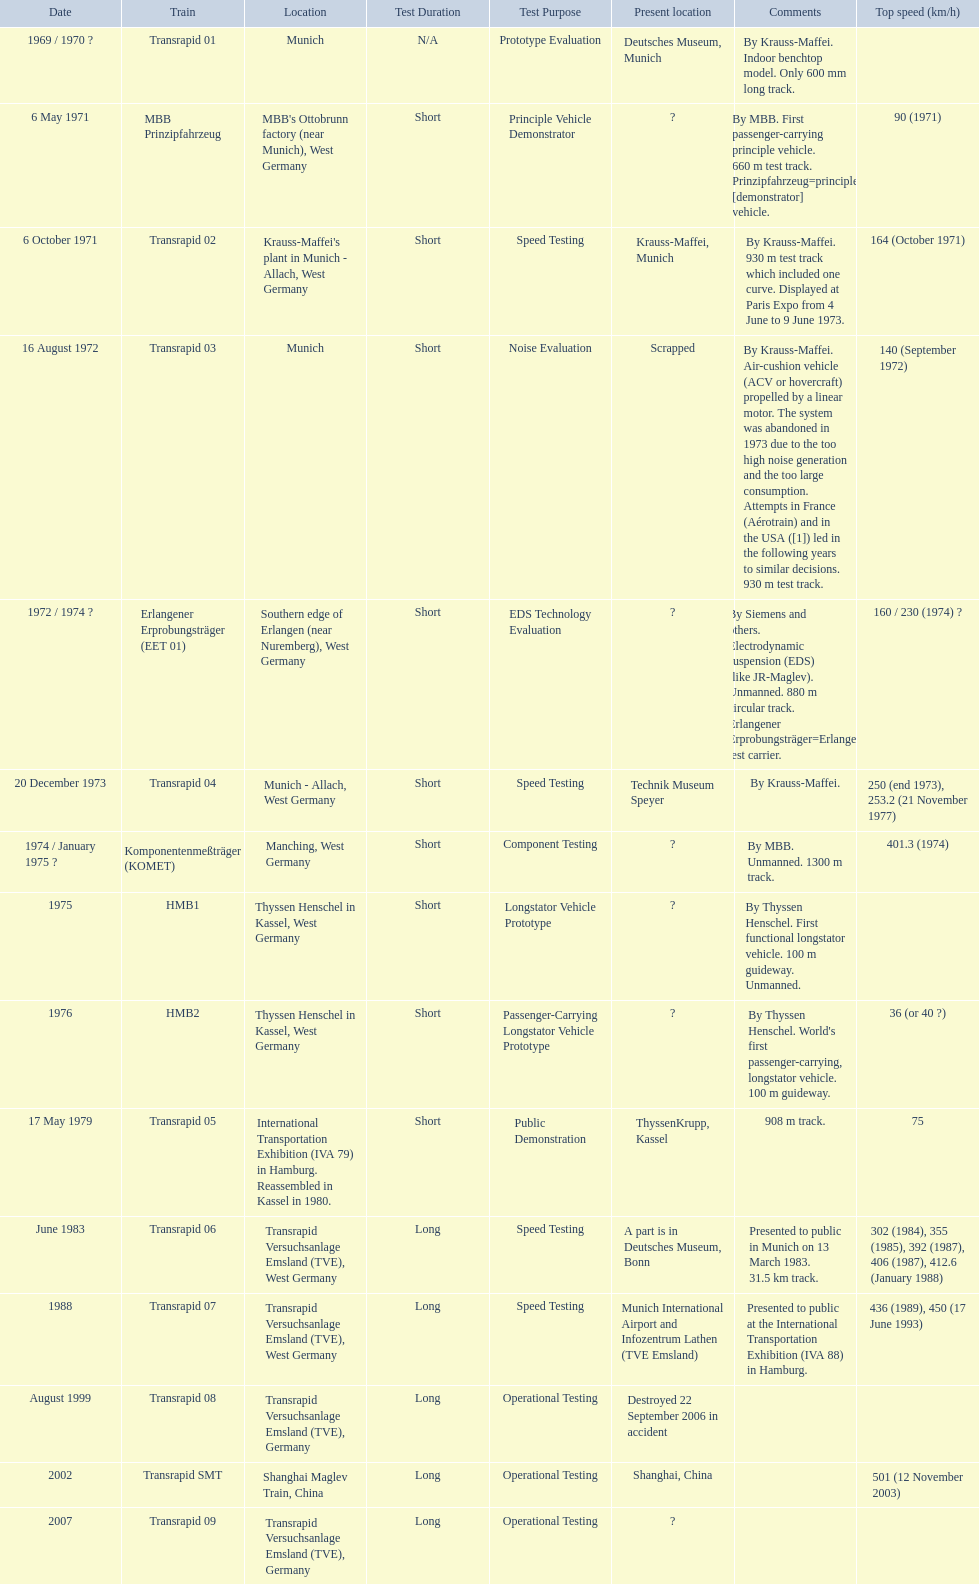What are the names of each transrapid train? Transrapid 01, MBB Prinzipfahrzeug, Transrapid 02, Transrapid 03, Erlangener Erprobungsträger (EET 01), Transrapid 04, Komponentenmeßträger (KOMET), HMB1, HMB2, Transrapid 05, Transrapid 06, Transrapid 07, Transrapid 08, Transrapid SMT, Transrapid 09. What are their listed top speeds? 90 (1971), 164 (October 1971), 140 (September 1972), 160 / 230 (1974) ?, 250 (end 1973), 253.2 (21 November 1977), 401.3 (1974), 36 (or 40 ?), 75, 302 (1984), 355 (1985), 392 (1987), 406 (1987), 412.6 (January 1988), 436 (1989), 450 (17 June 1993), 501 (12 November 2003). And which train operates at the fastest speed? Transrapid SMT. 